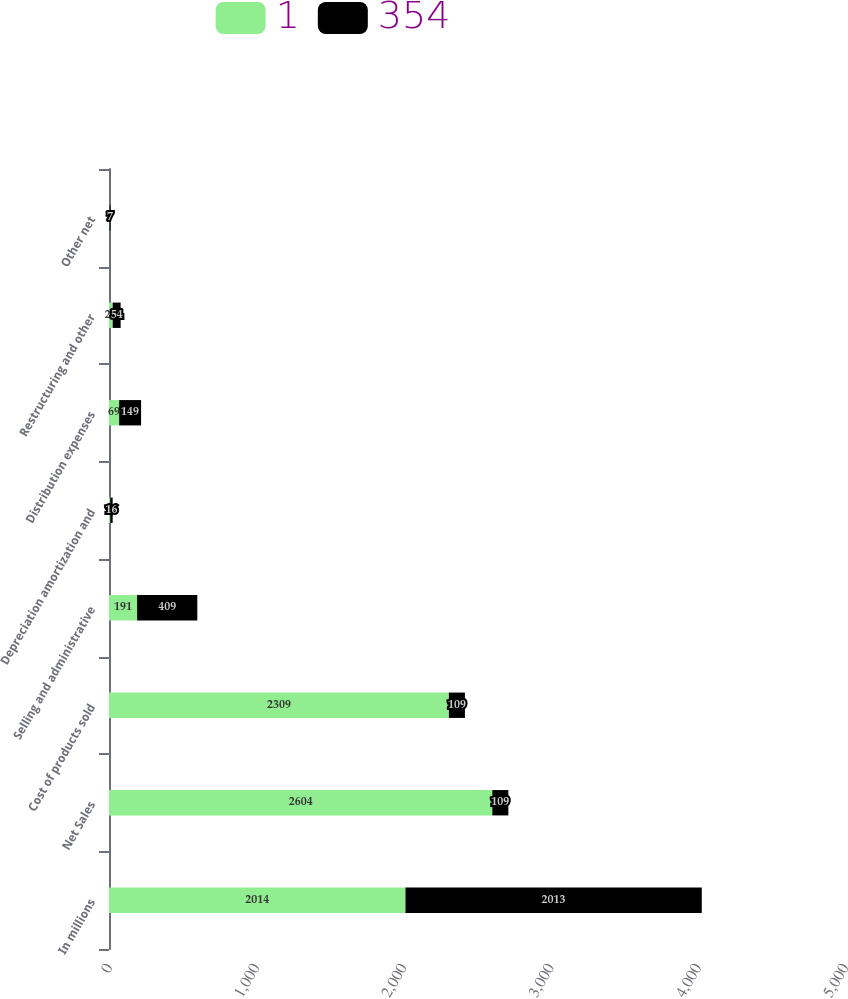Convert chart. <chart><loc_0><loc_0><loc_500><loc_500><stacked_bar_chart><ecel><fcel>In millions<fcel>Net Sales<fcel>Cost of products sold<fcel>Selling and administrative<fcel>Depreciation amortization and<fcel>Distribution expenses<fcel>Restructuring and other<fcel>Other net<nl><fcel>1<fcel>2014<fcel>2604<fcel>2309<fcel>191<fcel>9<fcel>69<fcel>25<fcel>3<nl><fcel>354<fcel>2013<fcel>109<fcel>109<fcel>409<fcel>16<fcel>149<fcel>54<fcel>7<nl></chart> 